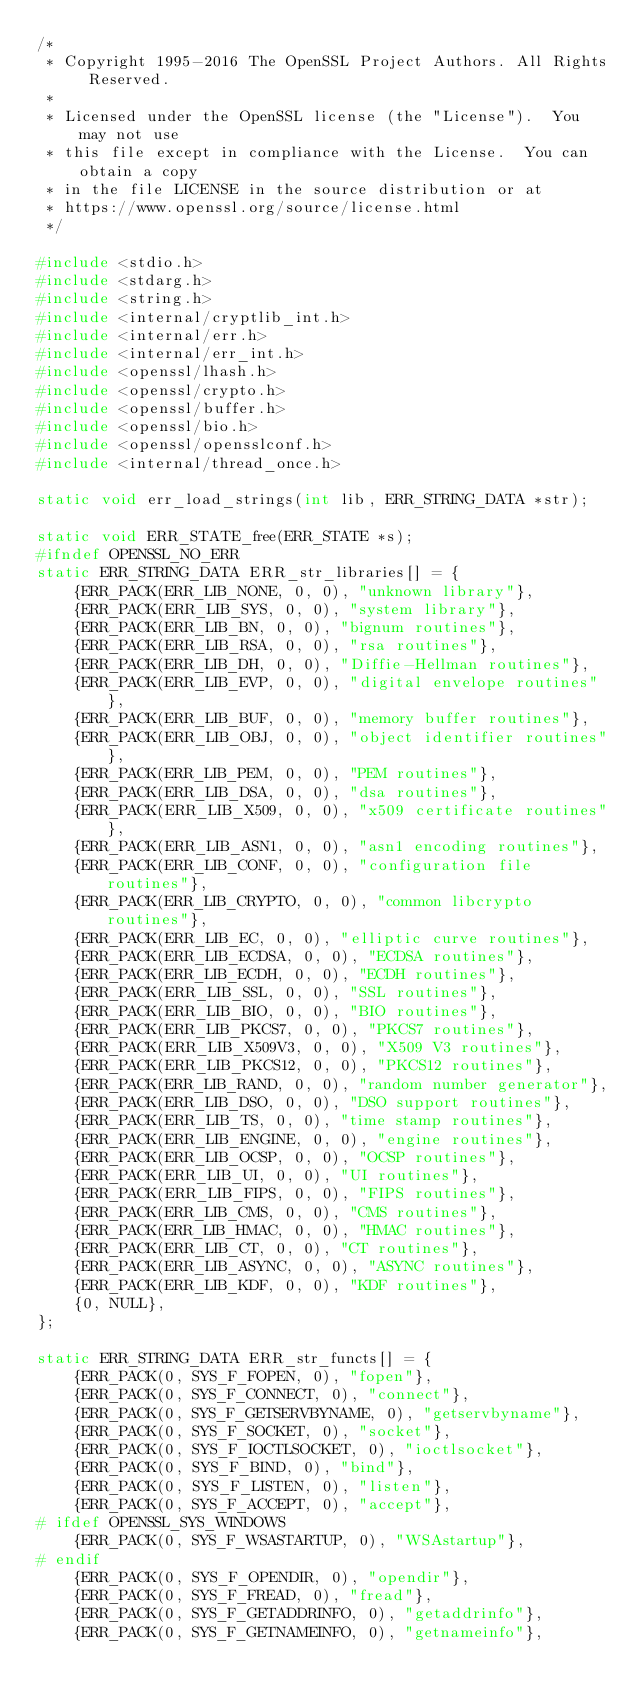Convert code to text. <code><loc_0><loc_0><loc_500><loc_500><_C_>/*
 * Copyright 1995-2016 The OpenSSL Project Authors. All Rights Reserved.
 *
 * Licensed under the OpenSSL license (the "License").  You may not use
 * this file except in compliance with the License.  You can obtain a copy
 * in the file LICENSE in the source distribution or at
 * https://www.openssl.org/source/license.html
 */

#include <stdio.h>
#include <stdarg.h>
#include <string.h>
#include <internal/cryptlib_int.h>
#include <internal/err.h>
#include <internal/err_int.h>
#include <openssl/lhash.h>
#include <openssl/crypto.h>
#include <openssl/buffer.h>
#include <openssl/bio.h>
#include <openssl/opensslconf.h>
#include <internal/thread_once.h>

static void err_load_strings(int lib, ERR_STRING_DATA *str);

static void ERR_STATE_free(ERR_STATE *s);
#ifndef OPENSSL_NO_ERR
static ERR_STRING_DATA ERR_str_libraries[] = {
    {ERR_PACK(ERR_LIB_NONE, 0, 0), "unknown library"},
    {ERR_PACK(ERR_LIB_SYS, 0, 0), "system library"},
    {ERR_PACK(ERR_LIB_BN, 0, 0), "bignum routines"},
    {ERR_PACK(ERR_LIB_RSA, 0, 0), "rsa routines"},
    {ERR_PACK(ERR_LIB_DH, 0, 0), "Diffie-Hellman routines"},
    {ERR_PACK(ERR_LIB_EVP, 0, 0), "digital envelope routines"},
    {ERR_PACK(ERR_LIB_BUF, 0, 0), "memory buffer routines"},
    {ERR_PACK(ERR_LIB_OBJ, 0, 0), "object identifier routines"},
    {ERR_PACK(ERR_LIB_PEM, 0, 0), "PEM routines"},
    {ERR_PACK(ERR_LIB_DSA, 0, 0), "dsa routines"},
    {ERR_PACK(ERR_LIB_X509, 0, 0), "x509 certificate routines"},
    {ERR_PACK(ERR_LIB_ASN1, 0, 0), "asn1 encoding routines"},
    {ERR_PACK(ERR_LIB_CONF, 0, 0), "configuration file routines"},
    {ERR_PACK(ERR_LIB_CRYPTO, 0, 0), "common libcrypto routines"},
    {ERR_PACK(ERR_LIB_EC, 0, 0), "elliptic curve routines"},
    {ERR_PACK(ERR_LIB_ECDSA, 0, 0), "ECDSA routines"},
    {ERR_PACK(ERR_LIB_ECDH, 0, 0), "ECDH routines"},
    {ERR_PACK(ERR_LIB_SSL, 0, 0), "SSL routines"},
    {ERR_PACK(ERR_LIB_BIO, 0, 0), "BIO routines"},
    {ERR_PACK(ERR_LIB_PKCS7, 0, 0), "PKCS7 routines"},
    {ERR_PACK(ERR_LIB_X509V3, 0, 0), "X509 V3 routines"},
    {ERR_PACK(ERR_LIB_PKCS12, 0, 0), "PKCS12 routines"},
    {ERR_PACK(ERR_LIB_RAND, 0, 0), "random number generator"},
    {ERR_PACK(ERR_LIB_DSO, 0, 0), "DSO support routines"},
    {ERR_PACK(ERR_LIB_TS, 0, 0), "time stamp routines"},
    {ERR_PACK(ERR_LIB_ENGINE, 0, 0), "engine routines"},
    {ERR_PACK(ERR_LIB_OCSP, 0, 0), "OCSP routines"},
    {ERR_PACK(ERR_LIB_UI, 0, 0), "UI routines"},
    {ERR_PACK(ERR_LIB_FIPS, 0, 0), "FIPS routines"},
    {ERR_PACK(ERR_LIB_CMS, 0, 0), "CMS routines"},
    {ERR_PACK(ERR_LIB_HMAC, 0, 0), "HMAC routines"},
    {ERR_PACK(ERR_LIB_CT, 0, 0), "CT routines"},
    {ERR_PACK(ERR_LIB_ASYNC, 0, 0), "ASYNC routines"},
    {ERR_PACK(ERR_LIB_KDF, 0, 0), "KDF routines"},
    {0, NULL},
};

static ERR_STRING_DATA ERR_str_functs[] = {
    {ERR_PACK(0, SYS_F_FOPEN, 0), "fopen"},
    {ERR_PACK(0, SYS_F_CONNECT, 0), "connect"},
    {ERR_PACK(0, SYS_F_GETSERVBYNAME, 0), "getservbyname"},
    {ERR_PACK(0, SYS_F_SOCKET, 0), "socket"},
    {ERR_PACK(0, SYS_F_IOCTLSOCKET, 0), "ioctlsocket"},
    {ERR_PACK(0, SYS_F_BIND, 0), "bind"},
    {ERR_PACK(0, SYS_F_LISTEN, 0), "listen"},
    {ERR_PACK(0, SYS_F_ACCEPT, 0), "accept"},
# ifdef OPENSSL_SYS_WINDOWS
    {ERR_PACK(0, SYS_F_WSASTARTUP, 0), "WSAstartup"},
# endif
    {ERR_PACK(0, SYS_F_OPENDIR, 0), "opendir"},
    {ERR_PACK(0, SYS_F_FREAD, 0), "fread"},
    {ERR_PACK(0, SYS_F_GETADDRINFO, 0), "getaddrinfo"},
    {ERR_PACK(0, SYS_F_GETNAMEINFO, 0), "getnameinfo"},</code> 